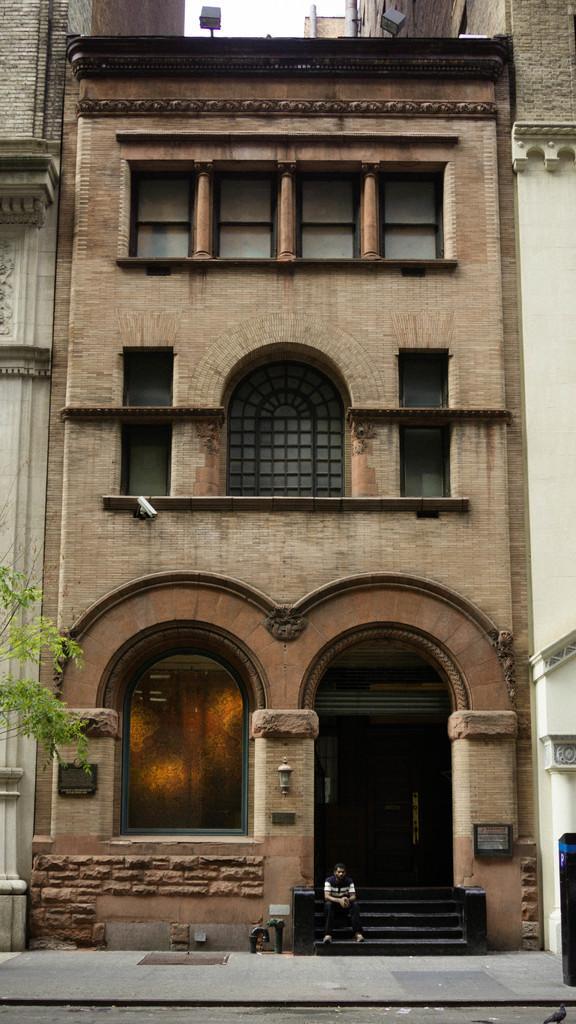Could you give a brief overview of what you see in this image? In this image we can see the building and here we can see the glass windows. Here we can see a closed circuit television on the wall. Here we can see a man sitting on the staircase and he is at the bottom. Here we can see a tree on the left side. 